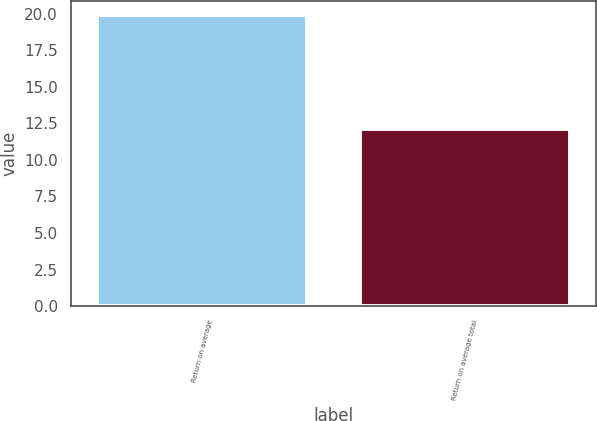<chart> <loc_0><loc_0><loc_500><loc_500><bar_chart><fcel>Return on average<fcel>Return on average total<nl><fcel>19.9<fcel>12.1<nl></chart> 